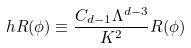Convert formula to latex. <formula><loc_0><loc_0><loc_500><loc_500>\ h R ( \phi ) \equiv \frac { C _ { d - 1 } \Lambda ^ { d - 3 } } { K ^ { 2 } } R ( \phi )</formula> 